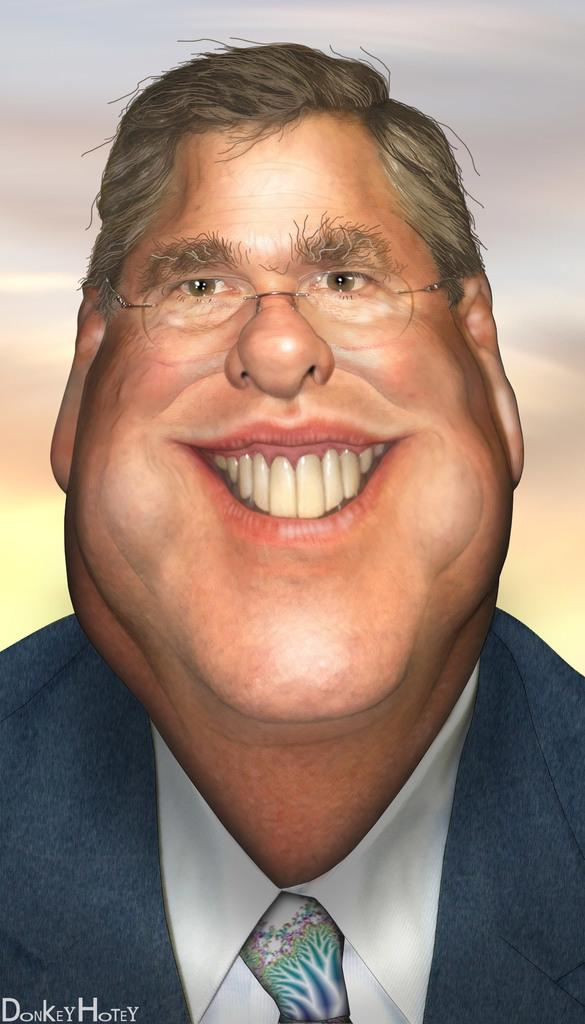What type of image is shown in the picture? The image contains an edited picture. What is the main subject of the edited picture? The edited picture depicts a person. What is the person wearing in the image? The person is wearing a suit. Can you see a parcel being delivered by a hose on a boat in the image? No, there is no parcel, hose, or boat present in the image. 